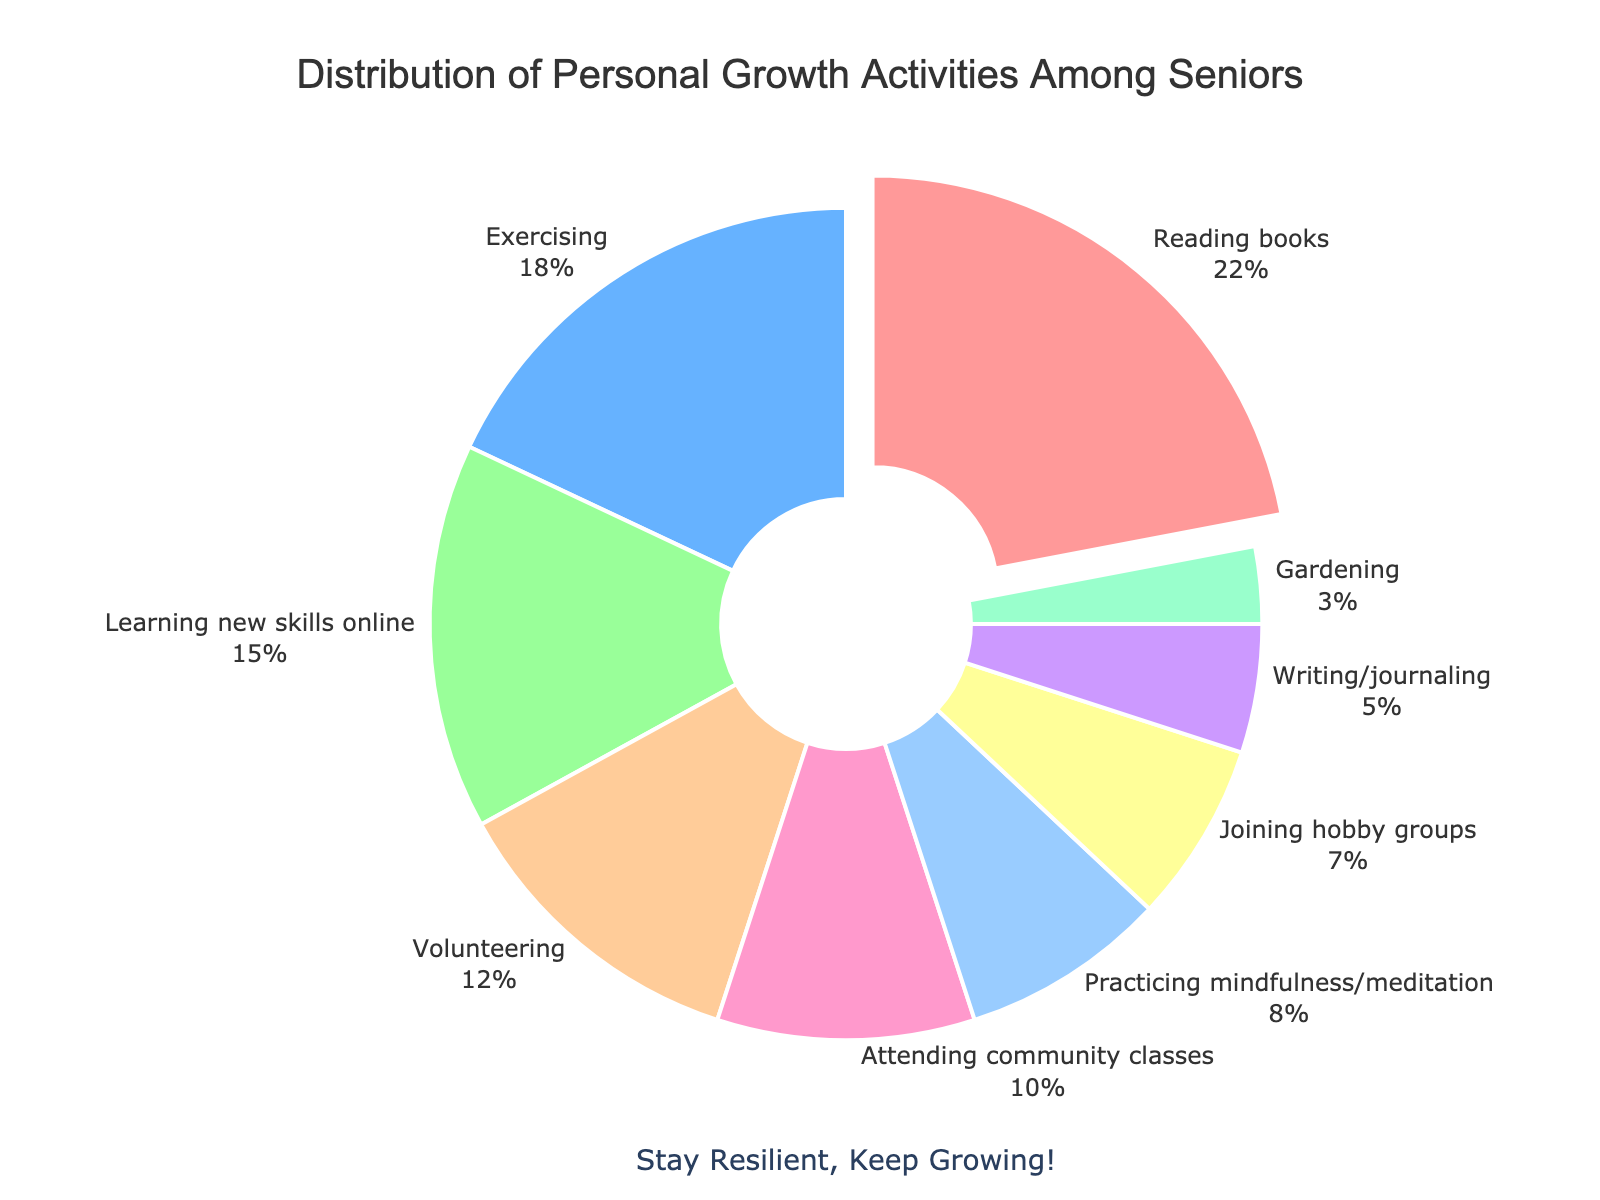What activity represents the largest portion of personal growth activities? The activity occupying the largest section of the pie chart is the one with the highest percentage value. Referring to the figure, reading books has the highest percentage at 22%.
Answer: Reading books What is the combined percentage of activities related to learning (reading books, learning new skills online, and attending community classes)? Sum the percentages of reading books (22%), learning new skills online (15%), and attending community classes (10%). The combined percentage is 22 + 15 + 10 = 47%.
Answer: 47% Which activity is practiced more, gardening or writing/journaling? Compare the percentages of gardening (3%) and writing/journaling (5%). Writing/journaling has a higher percentage than gardening.
Answer: Writing/journaling How many activities have a percentage less than 10%? Identify all activities with percentages less than 10%: practicing mindfulness/meditation (8%), joining hobby groups (7%), writing/journaling (5%), and gardening (3%). There are 4 such activities.
Answer: 4 What is the smallest portion of personal growth activities and its percentage? Locate the section that occupies the smallest area of the pie chart. Gardening has the smallest percentage at 3%.
Answer: Gardening, 3% What activities together account for 25% of the personal growth activities? Identify and sum percentages of activities until the total reaches or exceeds 25%. Practicing mindfulness/meditation (8%), joining hobby groups (7%), and writing/journaling (5%) together account for 8 + 7 + 5 = 20%, so adding gardening (3%) gives a total of 23%. Including attending community classes (10%) would exceed 25%, so the closest is 23% with the four activities listed.
Answer: Practicing mindfulness/meditation, joining hobby groups, writing/journaling, gardening Which is greater: the percentage of exercising or the combined percentage of volunteering and gardening? Compare the percentage of exercising (18%) to the sum of volunteering (12%) and gardening (3%). The combined percentage is 12 + 3 = 15%, which is less than 18%.
Answer: Exercising What is the average percentage of all personal growth activities listed? Sum the percentages of all activities and divide by the number of activities. The sum is 22 + 18 + 15 + 12 + 10 + 8 + 7 + 5 + 3 = 100. There are 9 activities, so the average is 100 / 9 ≈ 11.11%.
Answer: 11.11% What is the median percentage of the activities? Arrange the percentages in ascending order: 3, 5, 7, 8, 10, 12, 15, 18, 22. The middle value, or median, is the fifth value because there are nine activities. The fifth value is 10%.
Answer: 10% What is the difference in percentage between the largest and smallest activities? Identify the largest (reading books at 22%) and smallest (gardening at 3%) and calculate the difference: 22 - 3 = 19%.
Answer: 19% 